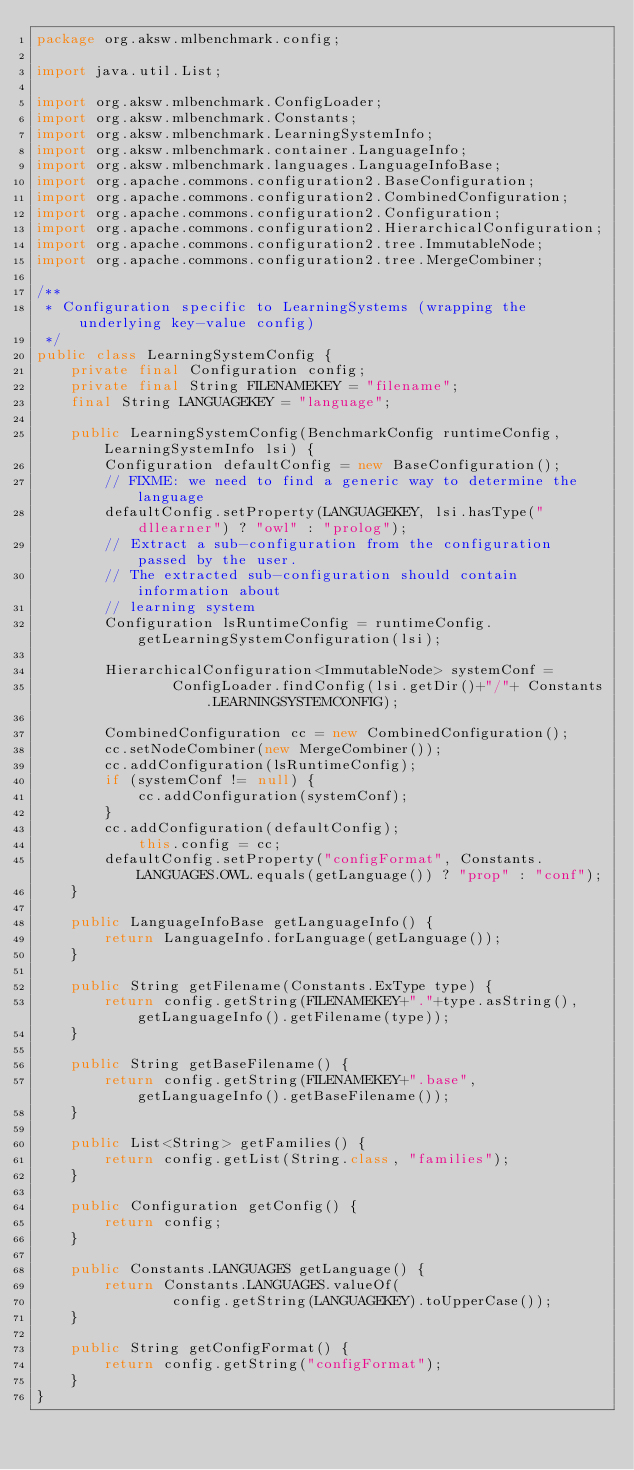<code> <loc_0><loc_0><loc_500><loc_500><_Java_>package org.aksw.mlbenchmark.config;

import java.util.List;

import org.aksw.mlbenchmark.ConfigLoader;
import org.aksw.mlbenchmark.Constants;
import org.aksw.mlbenchmark.LearningSystemInfo;
import org.aksw.mlbenchmark.container.LanguageInfo;
import org.aksw.mlbenchmark.languages.LanguageInfoBase;
import org.apache.commons.configuration2.BaseConfiguration;
import org.apache.commons.configuration2.CombinedConfiguration;
import org.apache.commons.configuration2.Configuration;
import org.apache.commons.configuration2.HierarchicalConfiguration;
import org.apache.commons.configuration2.tree.ImmutableNode;
import org.apache.commons.configuration2.tree.MergeCombiner;

/**
 * Configuration specific to LearningSystems (wrapping the underlying key-value config)
 */
public class LearningSystemConfig {
	private final Configuration config;
	private final String FILENAMEKEY = "filename";
	final String LANGUAGEKEY = "language";

	public LearningSystemConfig(BenchmarkConfig runtimeConfig, LearningSystemInfo lsi) {
		Configuration defaultConfig = new BaseConfiguration();
		// FIXME: we need to find a generic way to determine the language
		defaultConfig.setProperty(LANGUAGEKEY, lsi.hasType("dllearner") ? "owl" : "prolog");
		// Extract a sub-configuration from the configuration passed by the user.
		// The extracted sub-configuration should contain information about
		// learning system
		Configuration lsRuntimeConfig = runtimeConfig.getLearningSystemConfiguration(lsi);
		
		HierarchicalConfiguration<ImmutableNode> systemConf =
				ConfigLoader.findConfig(lsi.getDir()+"/"+ Constants.LEARNINGSYSTEMCONFIG);
		
		CombinedConfiguration cc = new CombinedConfiguration();
		cc.setNodeCombiner(new MergeCombiner());
		cc.addConfiguration(lsRuntimeConfig);
		if (systemConf != null) {
			cc.addConfiguration(systemConf);
		}
		cc.addConfiguration(defaultConfig);
			this.config = cc;
		defaultConfig.setProperty("configFormat", Constants.LANGUAGES.OWL.equals(getLanguage()) ? "prop" : "conf");
	}

	public LanguageInfoBase getLanguageInfo() {
		return LanguageInfo.forLanguage(getLanguage());
	}

	public String getFilename(Constants.ExType type) {
		return config.getString(FILENAMEKEY+"."+type.asString(), getLanguageInfo().getFilename(type));
	}

	public String getBaseFilename() {
		return config.getString(FILENAMEKEY+".base", getLanguageInfo().getBaseFilename());
	}

	public List<String> getFamilies() {
		return config.getList(String.class, "families");
	}

	public Configuration getConfig() {
		return config;
	}

	public Constants.LANGUAGES getLanguage() {
		return Constants.LANGUAGES.valueOf(
				config.getString(LANGUAGEKEY).toUpperCase());
	}

	public String getConfigFormat() {
		return config.getString("configFormat");
	}
}
</code> 